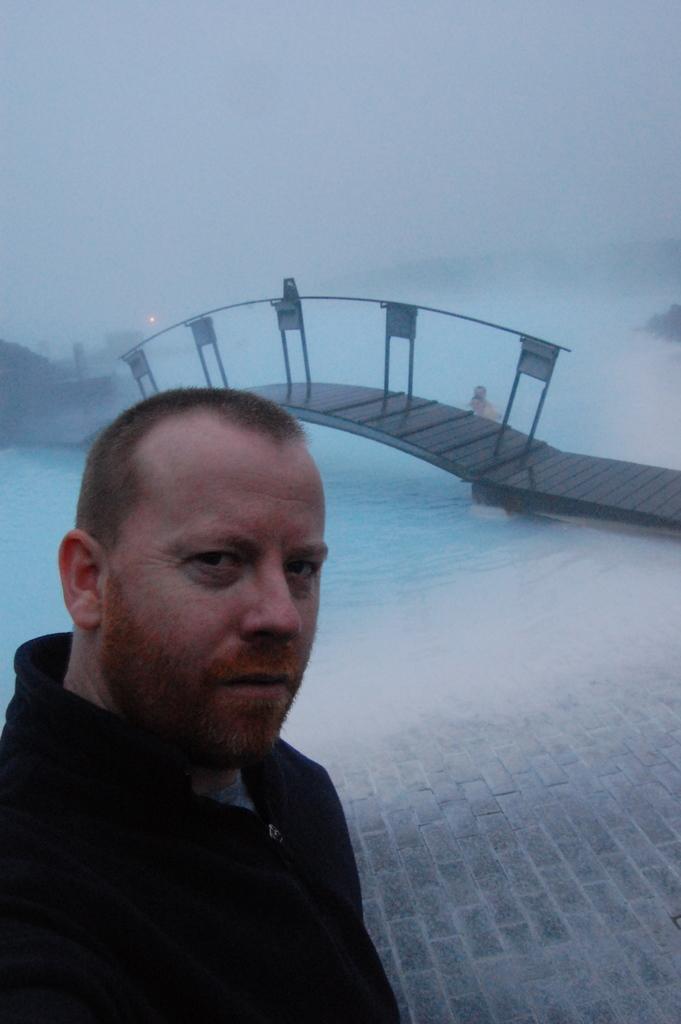Could you give a brief overview of what you see in this image? In this image I can see a person on the left side and at the top I can see the sky and in the middle I can see the bridge , under the bridge I can see water. 